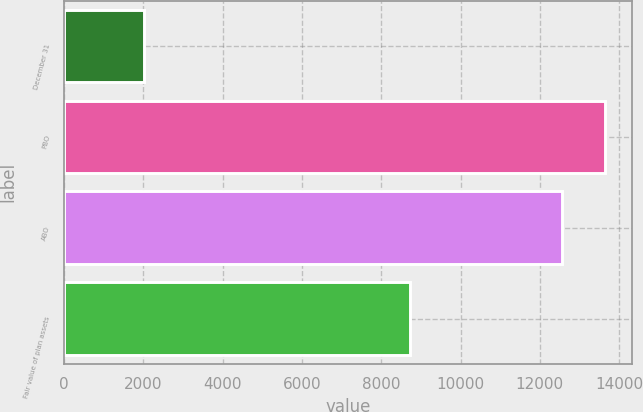Convert chart. <chart><loc_0><loc_0><loc_500><loc_500><bar_chart><fcel>December 31<fcel>PBO<fcel>ABO<fcel>Fair value of plan assets<nl><fcel>2016<fcel>13637.1<fcel>12557<fcel>8722<nl></chart> 